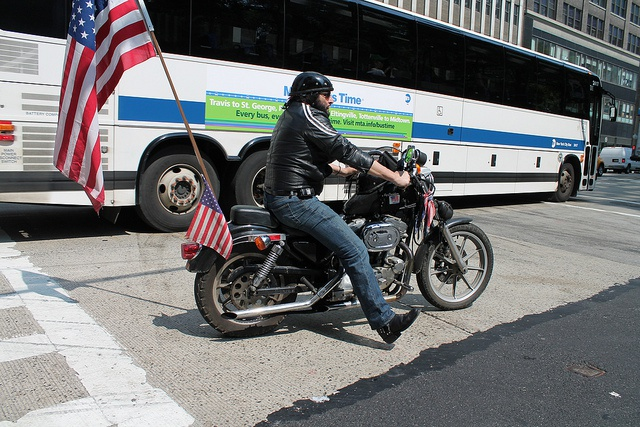Describe the objects in this image and their specific colors. I can see bus in black, lightgray, darkgray, and blue tones, motorcycle in black, gray, darkgray, and lightgray tones, people in black, gray, and blue tones, car in black, gray, and darkgray tones, and car in black, gray, and maroon tones in this image. 